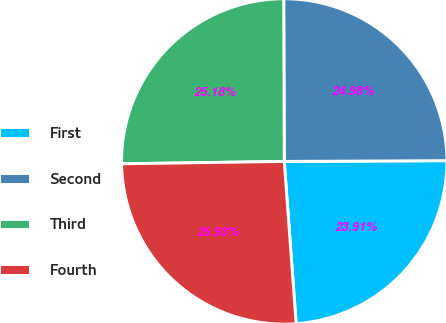Convert chart to OTSL. <chart><loc_0><loc_0><loc_500><loc_500><pie_chart><fcel>First<fcel>Second<fcel>Third<fcel>Fourth<nl><fcel>23.91%<fcel>24.98%<fcel>25.18%<fcel>25.93%<nl></chart> 